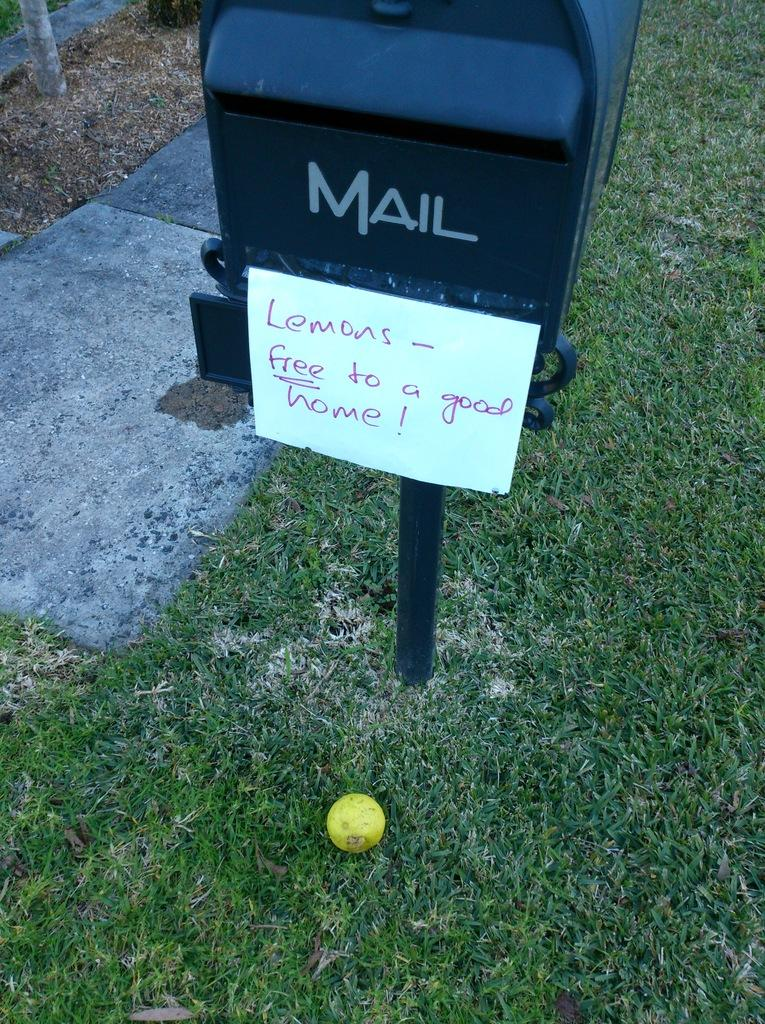What object is on the grass in the image? There is a ball on the grass in the image. What type of structure is present in the image? There is a mailbox in the image. What is the whiteboard used for in the image? The whiteboard has text on it, suggesting it is used for writing or displaying information. Where is the whiteboard located in relation to the mailbox? The whiteboard is visible on the mailbox. How much sugar is in the mailbox in the image? There is no sugar present in the mailbox in the image. 